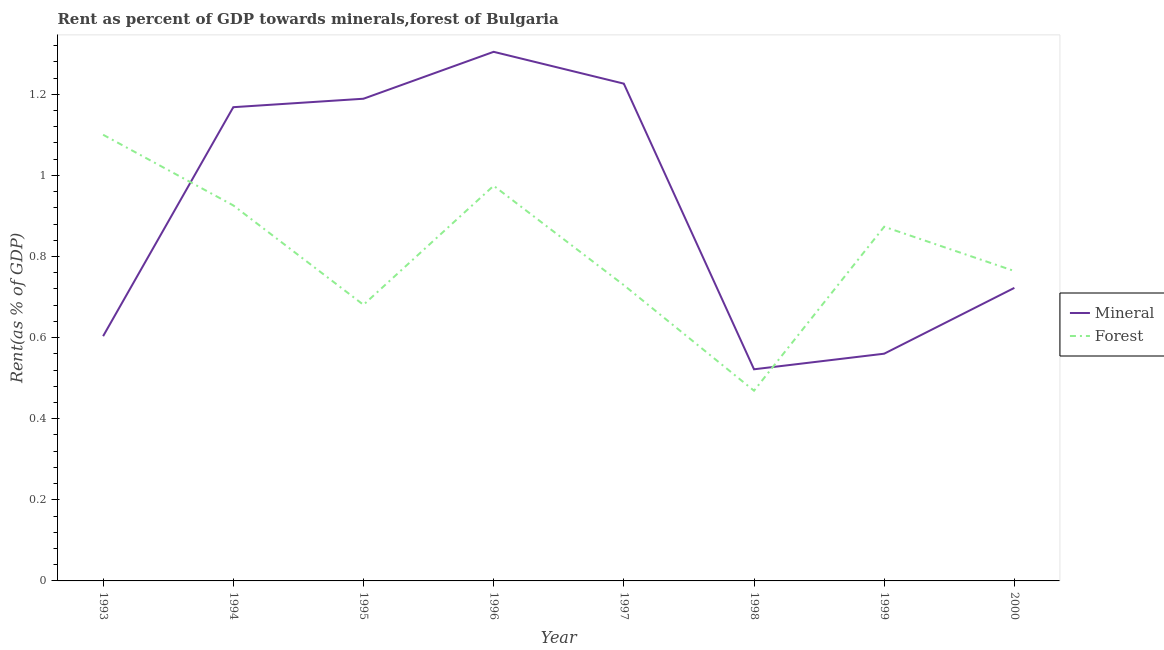How many different coloured lines are there?
Your answer should be very brief. 2. What is the forest rent in 1995?
Your answer should be very brief. 0.68. Across all years, what is the maximum forest rent?
Your answer should be compact. 1.1. Across all years, what is the minimum forest rent?
Offer a very short reply. 0.47. What is the total mineral rent in the graph?
Your answer should be compact. 7.3. What is the difference between the mineral rent in 1993 and that in 1997?
Your answer should be compact. -0.62. What is the difference between the mineral rent in 1996 and the forest rent in 1998?
Keep it short and to the point. 0.84. What is the average mineral rent per year?
Your response must be concise. 0.91. In the year 1995, what is the difference between the forest rent and mineral rent?
Make the answer very short. -0.51. What is the ratio of the forest rent in 1996 to that in 1998?
Your answer should be compact. 2.08. Is the forest rent in 1994 less than that in 1996?
Make the answer very short. Yes. What is the difference between the highest and the second highest mineral rent?
Keep it short and to the point. 0.08. What is the difference between the highest and the lowest forest rent?
Give a very brief answer. 0.63. Is the forest rent strictly greater than the mineral rent over the years?
Your answer should be very brief. No. How many lines are there?
Make the answer very short. 2. What is the difference between two consecutive major ticks on the Y-axis?
Your answer should be compact. 0.2. Where does the legend appear in the graph?
Offer a very short reply. Center right. How many legend labels are there?
Offer a very short reply. 2. How are the legend labels stacked?
Your answer should be very brief. Vertical. What is the title of the graph?
Offer a terse response. Rent as percent of GDP towards minerals,forest of Bulgaria. What is the label or title of the X-axis?
Offer a terse response. Year. What is the label or title of the Y-axis?
Ensure brevity in your answer.  Rent(as % of GDP). What is the Rent(as % of GDP) of Mineral in 1993?
Offer a very short reply. 0.6. What is the Rent(as % of GDP) of Forest in 1993?
Keep it short and to the point. 1.1. What is the Rent(as % of GDP) of Mineral in 1994?
Offer a very short reply. 1.17. What is the Rent(as % of GDP) of Forest in 1994?
Offer a very short reply. 0.93. What is the Rent(as % of GDP) of Mineral in 1995?
Provide a short and direct response. 1.19. What is the Rent(as % of GDP) in Forest in 1995?
Make the answer very short. 0.68. What is the Rent(as % of GDP) in Mineral in 1996?
Provide a short and direct response. 1.3. What is the Rent(as % of GDP) of Forest in 1996?
Your answer should be very brief. 0.97. What is the Rent(as % of GDP) in Mineral in 1997?
Your answer should be very brief. 1.23. What is the Rent(as % of GDP) of Forest in 1997?
Offer a terse response. 0.73. What is the Rent(as % of GDP) in Mineral in 1998?
Your answer should be compact. 0.52. What is the Rent(as % of GDP) in Forest in 1998?
Make the answer very short. 0.47. What is the Rent(as % of GDP) of Mineral in 1999?
Offer a terse response. 0.56. What is the Rent(as % of GDP) of Forest in 1999?
Provide a short and direct response. 0.87. What is the Rent(as % of GDP) of Mineral in 2000?
Offer a terse response. 0.72. What is the Rent(as % of GDP) in Forest in 2000?
Make the answer very short. 0.76. Across all years, what is the maximum Rent(as % of GDP) in Mineral?
Ensure brevity in your answer.  1.3. Across all years, what is the maximum Rent(as % of GDP) of Forest?
Offer a terse response. 1.1. Across all years, what is the minimum Rent(as % of GDP) of Mineral?
Keep it short and to the point. 0.52. Across all years, what is the minimum Rent(as % of GDP) in Forest?
Ensure brevity in your answer.  0.47. What is the total Rent(as % of GDP) of Mineral in the graph?
Your answer should be compact. 7.3. What is the total Rent(as % of GDP) in Forest in the graph?
Offer a very short reply. 6.52. What is the difference between the Rent(as % of GDP) of Mineral in 1993 and that in 1994?
Offer a terse response. -0.56. What is the difference between the Rent(as % of GDP) in Forest in 1993 and that in 1994?
Provide a short and direct response. 0.17. What is the difference between the Rent(as % of GDP) of Mineral in 1993 and that in 1995?
Your answer should be compact. -0.59. What is the difference between the Rent(as % of GDP) of Forest in 1993 and that in 1995?
Give a very brief answer. 0.42. What is the difference between the Rent(as % of GDP) of Mineral in 1993 and that in 1996?
Offer a very short reply. -0.7. What is the difference between the Rent(as % of GDP) of Forest in 1993 and that in 1996?
Offer a terse response. 0.13. What is the difference between the Rent(as % of GDP) in Mineral in 1993 and that in 1997?
Offer a very short reply. -0.62. What is the difference between the Rent(as % of GDP) in Forest in 1993 and that in 1997?
Ensure brevity in your answer.  0.37. What is the difference between the Rent(as % of GDP) of Mineral in 1993 and that in 1998?
Give a very brief answer. 0.08. What is the difference between the Rent(as % of GDP) of Forest in 1993 and that in 1998?
Provide a short and direct response. 0.63. What is the difference between the Rent(as % of GDP) of Mineral in 1993 and that in 1999?
Provide a short and direct response. 0.04. What is the difference between the Rent(as % of GDP) in Forest in 1993 and that in 1999?
Keep it short and to the point. 0.23. What is the difference between the Rent(as % of GDP) in Mineral in 1993 and that in 2000?
Offer a terse response. -0.12. What is the difference between the Rent(as % of GDP) of Forest in 1993 and that in 2000?
Your response must be concise. 0.34. What is the difference between the Rent(as % of GDP) in Mineral in 1994 and that in 1995?
Your answer should be compact. -0.02. What is the difference between the Rent(as % of GDP) in Forest in 1994 and that in 1995?
Provide a succinct answer. 0.25. What is the difference between the Rent(as % of GDP) of Mineral in 1994 and that in 1996?
Your answer should be compact. -0.14. What is the difference between the Rent(as % of GDP) of Forest in 1994 and that in 1996?
Provide a short and direct response. -0.05. What is the difference between the Rent(as % of GDP) in Mineral in 1994 and that in 1997?
Offer a terse response. -0.06. What is the difference between the Rent(as % of GDP) in Forest in 1994 and that in 1997?
Your answer should be very brief. 0.2. What is the difference between the Rent(as % of GDP) of Mineral in 1994 and that in 1998?
Provide a short and direct response. 0.65. What is the difference between the Rent(as % of GDP) in Forest in 1994 and that in 1998?
Your response must be concise. 0.46. What is the difference between the Rent(as % of GDP) of Mineral in 1994 and that in 1999?
Make the answer very short. 0.61. What is the difference between the Rent(as % of GDP) of Forest in 1994 and that in 1999?
Make the answer very short. 0.05. What is the difference between the Rent(as % of GDP) of Mineral in 1994 and that in 2000?
Your answer should be compact. 0.45. What is the difference between the Rent(as % of GDP) of Forest in 1994 and that in 2000?
Provide a short and direct response. 0.16. What is the difference between the Rent(as % of GDP) in Mineral in 1995 and that in 1996?
Provide a succinct answer. -0.12. What is the difference between the Rent(as % of GDP) of Forest in 1995 and that in 1996?
Your answer should be compact. -0.29. What is the difference between the Rent(as % of GDP) of Mineral in 1995 and that in 1997?
Your response must be concise. -0.04. What is the difference between the Rent(as % of GDP) in Forest in 1995 and that in 1997?
Your answer should be very brief. -0.05. What is the difference between the Rent(as % of GDP) of Mineral in 1995 and that in 1998?
Keep it short and to the point. 0.67. What is the difference between the Rent(as % of GDP) of Forest in 1995 and that in 1998?
Give a very brief answer. 0.21. What is the difference between the Rent(as % of GDP) in Mineral in 1995 and that in 1999?
Make the answer very short. 0.63. What is the difference between the Rent(as % of GDP) in Forest in 1995 and that in 1999?
Offer a very short reply. -0.19. What is the difference between the Rent(as % of GDP) of Mineral in 1995 and that in 2000?
Offer a very short reply. 0.47. What is the difference between the Rent(as % of GDP) of Forest in 1995 and that in 2000?
Your answer should be compact. -0.08. What is the difference between the Rent(as % of GDP) in Mineral in 1996 and that in 1997?
Provide a short and direct response. 0.08. What is the difference between the Rent(as % of GDP) in Forest in 1996 and that in 1997?
Your answer should be very brief. 0.25. What is the difference between the Rent(as % of GDP) of Mineral in 1996 and that in 1998?
Offer a very short reply. 0.78. What is the difference between the Rent(as % of GDP) of Forest in 1996 and that in 1998?
Your answer should be very brief. 0.51. What is the difference between the Rent(as % of GDP) of Mineral in 1996 and that in 1999?
Offer a very short reply. 0.74. What is the difference between the Rent(as % of GDP) of Forest in 1996 and that in 1999?
Keep it short and to the point. 0.1. What is the difference between the Rent(as % of GDP) in Mineral in 1996 and that in 2000?
Provide a short and direct response. 0.58. What is the difference between the Rent(as % of GDP) of Forest in 1996 and that in 2000?
Your answer should be very brief. 0.21. What is the difference between the Rent(as % of GDP) of Mineral in 1997 and that in 1998?
Your answer should be compact. 0.7. What is the difference between the Rent(as % of GDP) in Forest in 1997 and that in 1998?
Your answer should be very brief. 0.26. What is the difference between the Rent(as % of GDP) in Mineral in 1997 and that in 1999?
Give a very brief answer. 0.67. What is the difference between the Rent(as % of GDP) in Forest in 1997 and that in 1999?
Offer a very short reply. -0.14. What is the difference between the Rent(as % of GDP) of Mineral in 1997 and that in 2000?
Provide a short and direct response. 0.5. What is the difference between the Rent(as % of GDP) of Forest in 1997 and that in 2000?
Offer a very short reply. -0.03. What is the difference between the Rent(as % of GDP) of Mineral in 1998 and that in 1999?
Offer a very short reply. -0.04. What is the difference between the Rent(as % of GDP) of Forest in 1998 and that in 1999?
Keep it short and to the point. -0.4. What is the difference between the Rent(as % of GDP) of Mineral in 1998 and that in 2000?
Ensure brevity in your answer.  -0.2. What is the difference between the Rent(as % of GDP) of Forest in 1998 and that in 2000?
Your answer should be compact. -0.3. What is the difference between the Rent(as % of GDP) in Mineral in 1999 and that in 2000?
Offer a terse response. -0.16. What is the difference between the Rent(as % of GDP) of Forest in 1999 and that in 2000?
Offer a very short reply. 0.11. What is the difference between the Rent(as % of GDP) in Mineral in 1993 and the Rent(as % of GDP) in Forest in 1994?
Provide a succinct answer. -0.32. What is the difference between the Rent(as % of GDP) of Mineral in 1993 and the Rent(as % of GDP) of Forest in 1995?
Offer a terse response. -0.08. What is the difference between the Rent(as % of GDP) of Mineral in 1993 and the Rent(as % of GDP) of Forest in 1996?
Provide a short and direct response. -0.37. What is the difference between the Rent(as % of GDP) in Mineral in 1993 and the Rent(as % of GDP) in Forest in 1997?
Offer a very short reply. -0.13. What is the difference between the Rent(as % of GDP) in Mineral in 1993 and the Rent(as % of GDP) in Forest in 1998?
Your response must be concise. 0.13. What is the difference between the Rent(as % of GDP) of Mineral in 1993 and the Rent(as % of GDP) of Forest in 1999?
Your response must be concise. -0.27. What is the difference between the Rent(as % of GDP) in Mineral in 1993 and the Rent(as % of GDP) in Forest in 2000?
Offer a terse response. -0.16. What is the difference between the Rent(as % of GDP) in Mineral in 1994 and the Rent(as % of GDP) in Forest in 1995?
Provide a short and direct response. 0.49. What is the difference between the Rent(as % of GDP) of Mineral in 1994 and the Rent(as % of GDP) of Forest in 1996?
Ensure brevity in your answer.  0.19. What is the difference between the Rent(as % of GDP) in Mineral in 1994 and the Rent(as % of GDP) in Forest in 1997?
Offer a terse response. 0.44. What is the difference between the Rent(as % of GDP) of Mineral in 1994 and the Rent(as % of GDP) of Forest in 1998?
Ensure brevity in your answer.  0.7. What is the difference between the Rent(as % of GDP) in Mineral in 1994 and the Rent(as % of GDP) in Forest in 1999?
Make the answer very short. 0.29. What is the difference between the Rent(as % of GDP) in Mineral in 1994 and the Rent(as % of GDP) in Forest in 2000?
Keep it short and to the point. 0.4. What is the difference between the Rent(as % of GDP) in Mineral in 1995 and the Rent(as % of GDP) in Forest in 1996?
Provide a short and direct response. 0.21. What is the difference between the Rent(as % of GDP) in Mineral in 1995 and the Rent(as % of GDP) in Forest in 1997?
Offer a very short reply. 0.46. What is the difference between the Rent(as % of GDP) of Mineral in 1995 and the Rent(as % of GDP) of Forest in 1998?
Provide a short and direct response. 0.72. What is the difference between the Rent(as % of GDP) of Mineral in 1995 and the Rent(as % of GDP) of Forest in 1999?
Give a very brief answer. 0.32. What is the difference between the Rent(as % of GDP) in Mineral in 1995 and the Rent(as % of GDP) in Forest in 2000?
Give a very brief answer. 0.42. What is the difference between the Rent(as % of GDP) of Mineral in 1996 and the Rent(as % of GDP) of Forest in 1997?
Offer a terse response. 0.58. What is the difference between the Rent(as % of GDP) in Mineral in 1996 and the Rent(as % of GDP) in Forest in 1998?
Your response must be concise. 0.84. What is the difference between the Rent(as % of GDP) in Mineral in 1996 and the Rent(as % of GDP) in Forest in 1999?
Make the answer very short. 0.43. What is the difference between the Rent(as % of GDP) in Mineral in 1996 and the Rent(as % of GDP) in Forest in 2000?
Give a very brief answer. 0.54. What is the difference between the Rent(as % of GDP) of Mineral in 1997 and the Rent(as % of GDP) of Forest in 1998?
Give a very brief answer. 0.76. What is the difference between the Rent(as % of GDP) of Mineral in 1997 and the Rent(as % of GDP) of Forest in 1999?
Make the answer very short. 0.35. What is the difference between the Rent(as % of GDP) of Mineral in 1997 and the Rent(as % of GDP) of Forest in 2000?
Keep it short and to the point. 0.46. What is the difference between the Rent(as % of GDP) of Mineral in 1998 and the Rent(as % of GDP) of Forest in 1999?
Provide a succinct answer. -0.35. What is the difference between the Rent(as % of GDP) of Mineral in 1998 and the Rent(as % of GDP) of Forest in 2000?
Keep it short and to the point. -0.24. What is the difference between the Rent(as % of GDP) in Mineral in 1999 and the Rent(as % of GDP) in Forest in 2000?
Offer a very short reply. -0.2. What is the average Rent(as % of GDP) of Mineral per year?
Keep it short and to the point. 0.91. What is the average Rent(as % of GDP) of Forest per year?
Make the answer very short. 0.81. In the year 1993, what is the difference between the Rent(as % of GDP) in Mineral and Rent(as % of GDP) in Forest?
Provide a succinct answer. -0.5. In the year 1994, what is the difference between the Rent(as % of GDP) of Mineral and Rent(as % of GDP) of Forest?
Your answer should be very brief. 0.24. In the year 1995, what is the difference between the Rent(as % of GDP) in Mineral and Rent(as % of GDP) in Forest?
Ensure brevity in your answer.  0.51. In the year 1996, what is the difference between the Rent(as % of GDP) in Mineral and Rent(as % of GDP) in Forest?
Provide a succinct answer. 0.33. In the year 1997, what is the difference between the Rent(as % of GDP) in Mineral and Rent(as % of GDP) in Forest?
Your response must be concise. 0.5. In the year 1998, what is the difference between the Rent(as % of GDP) of Mineral and Rent(as % of GDP) of Forest?
Provide a succinct answer. 0.05. In the year 1999, what is the difference between the Rent(as % of GDP) in Mineral and Rent(as % of GDP) in Forest?
Ensure brevity in your answer.  -0.31. In the year 2000, what is the difference between the Rent(as % of GDP) in Mineral and Rent(as % of GDP) in Forest?
Your answer should be compact. -0.04. What is the ratio of the Rent(as % of GDP) in Mineral in 1993 to that in 1994?
Provide a succinct answer. 0.52. What is the ratio of the Rent(as % of GDP) in Forest in 1993 to that in 1994?
Offer a terse response. 1.19. What is the ratio of the Rent(as % of GDP) of Mineral in 1993 to that in 1995?
Provide a short and direct response. 0.51. What is the ratio of the Rent(as % of GDP) of Forest in 1993 to that in 1995?
Offer a terse response. 1.62. What is the ratio of the Rent(as % of GDP) of Mineral in 1993 to that in 1996?
Make the answer very short. 0.46. What is the ratio of the Rent(as % of GDP) of Forest in 1993 to that in 1996?
Keep it short and to the point. 1.13. What is the ratio of the Rent(as % of GDP) in Mineral in 1993 to that in 1997?
Offer a very short reply. 0.49. What is the ratio of the Rent(as % of GDP) of Forest in 1993 to that in 1997?
Your answer should be very brief. 1.51. What is the ratio of the Rent(as % of GDP) of Mineral in 1993 to that in 1998?
Give a very brief answer. 1.16. What is the ratio of the Rent(as % of GDP) in Forest in 1993 to that in 1998?
Your response must be concise. 2.35. What is the ratio of the Rent(as % of GDP) in Mineral in 1993 to that in 1999?
Offer a terse response. 1.08. What is the ratio of the Rent(as % of GDP) in Forest in 1993 to that in 1999?
Keep it short and to the point. 1.26. What is the ratio of the Rent(as % of GDP) in Mineral in 1993 to that in 2000?
Make the answer very short. 0.84. What is the ratio of the Rent(as % of GDP) of Forest in 1993 to that in 2000?
Ensure brevity in your answer.  1.44. What is the ratio of the Rent(as % of GDP) in Mineral in 1994 to that in 1995?
Your answer should be very brief. 0.98. What is the ratio of the Rent(as % of GDP) in Forest in 1994 to that in 1995?
Keep it short and to the point. 1.36. What is the ratio of the Rent(as % of GDP) of Mineral in 1994 to that in 1996?
Ensure brevity in your answer.  0.9. What is the ratio of the Rent(as % of GDP) of Forest in 1994 to that in 1996?
Your answer should be very brief. 0.95. What is the ratio of the Rent(as % of GDP) in Mineral in 1994 to that in 1997?
Your response must be concise. 0.95. What is the ratio of the Rent(as % of GDP) of Forest in 1994 to that in 1997?
Your response must be concise. 1.27. What is the ratio of the Rent(as % of GDP) in Mineral in 1994 to that in 1998?
Offer a terse response. 2.24. What is the ratio of the Rent(as % of GDP) in Forest in 1994 to that in 1998?
Provide a short and direct response. 1.97. What is the ratio of the Rent(as % of GDP) of Mineral in 1994 to that in 1999?
Offer a terse response. 2.08. What is the ratio of the Rent(as % of GDP) in Forest in 1994 to that in 1999?
Provide a succinct answer. 1.06. What is the ratio of the Rent(as % of GDP) of Mineral in 1994 to that in 2000?
Your response must be concise. 1.62. What is the ratio of the Rent(as % of GDP) of Forest in 1994 to that in 2000?
Ensure brevity in your answer.  1.21. What is the ratio of the Rent(as % of GDP) of Mineral in 1995 to that in 1996?
Your answer should be compact. 0.91. What is the ratio of the Rent(as % of GDP) of Forest in 1995 to that in 1996?
Make the answer very short. 0.7. What is the ratio of the Rent(as % of GDP) in Mineral in 1995 to that in 1997?
Give a very brief answer. 0.97. What is the ratio of the Rent(as % of GDP) of Forest in 1995 to that in 1997?
Give a very brief answer. 0.93. What is the ratio of the Rent(as % of GDP) of Mineral in 1995 to that in 1998?
Provide a succinct answer. 2.28. What is the ratio of the Rent(as % of GDP) of Forest in 1995 to that in 1998?
Provide a succinct answer. 1.45. What is the ratio of the Rent(as % of GDP) in Mineral in 1995 to that in 1999?
Keep it short and to the point. 2.12. What is the ratio of the Rent(as % of GDP) of Forest in 1995 to that in 1999?
Keep it short and to the point. 0.78. What is the ratio of the Rent(as % of GDP) of Mineral in 1995 to that in 2000?
Your response must be concise. 1.65. What is the ratio of the Rent(as % of GDP) of Forest in 1995 to that in 2000?
Ensure brevity in your answer.  0.89. What is the ratio of the Rent(as % of GDP) of Mineral in 1996 to that in 1997?
Your answer should be compact. 1.06. What is the ratio of the Rent(as % of GDP) of Forest in 1996 to that in 1997?
Make the answer very short. 1.34. What is the ratio of the Rent(as % of GDP) in Mineral in 1996 to that in 1998?
Offer a very short reply. 2.5. What is the ratio of the Rent(as % of GDP) of Forest in 1996 to that in 1998?
Keep it short and to the point. 2.08. What is the ratio of the Rent(as % of GDP) of Mineral in 1996 to that in 1999?
Offer a terse response. 2.33. What is the ratio of the Rent(as % of GDP) in Forest in 1996 to that in 1999?
Your response must be concise. 1.12. What is the ratio of the Rent(as % of GDP) in Mineral in 1996 to that in 2000?
Offer a very short reply. 1.81. What is the ratio of the Rent(as % of GDP) of Forest in 1996 to that in 2000?
Make the answer very short. 1.28. What is the ratio of the Rent(as % of GDP) in Mineral in 1997 to that in 1998?
Provide a short and direct response. 2.35. What is the ratio of the Rent(as % of GDP) of Forest in 1997 to that in 1998?
Give a very brief answer. 1.55. What is the ratio of the Rent(as % of GDP) in Mineral in 1997 to that in 1999?
Offer a very short reply. 2.19. What is the ratio of the Rent(as % of GDP) in Forest in 1997 to that in 1999?
Provide a short and direct response. 0.84. What is the ratio of the Rent(as % of GDP) of Mineral in 1997 to that in 2000?
Your answer should be very brief. 1.7. What is the ratio of the Rent(as % of GDP) in Forest in 1997 to that in 2000?
Offer a terse response. 0.95. What is the ratio of the Rent(as % of GDP) in Mineral in 1998 to that in 1999?
Offer a terse response. 0.93. What is the ratio of the Rent(as % of GDP) of Forest in 1998 to that in 1999?
Offer a terse response. 0.54. What is the ratio of the Rent(as % of GDP) of Mineral in 1998 to that in 2000?
Your answer should be compact. 0.72. What is the ratio of the Rent(as % of GDP) of Forest in 1998 to that in 2000?
Make the answer very short. 0.61. What is the ratio of the Rent(as % of GDP) of Mineral in 1999 to that in 2000?
Your answer should be compact. 0.78. What is the ratio of the Rent(as % of GDP) of Forest in 1999 to that in 2000?
Your response must be concise. 1.14. What is the difference between the highest and the second highest Rent(as % of GDP) of Mineral?
Give a very brief answer. 0.08. What is the difference between the highest and the second highest Rent(as % of GDP) in Forest?
Provide a short and direct response. 0.13. What is the difference between the highest and the lowest Rent(as % of GDP) of Mineral?
Make the answer very short. 0.78. What is the difference between the highest and the lowest Rent(as % of GDP) of Forest?
Ensure brevity in your answer.  0.63. 